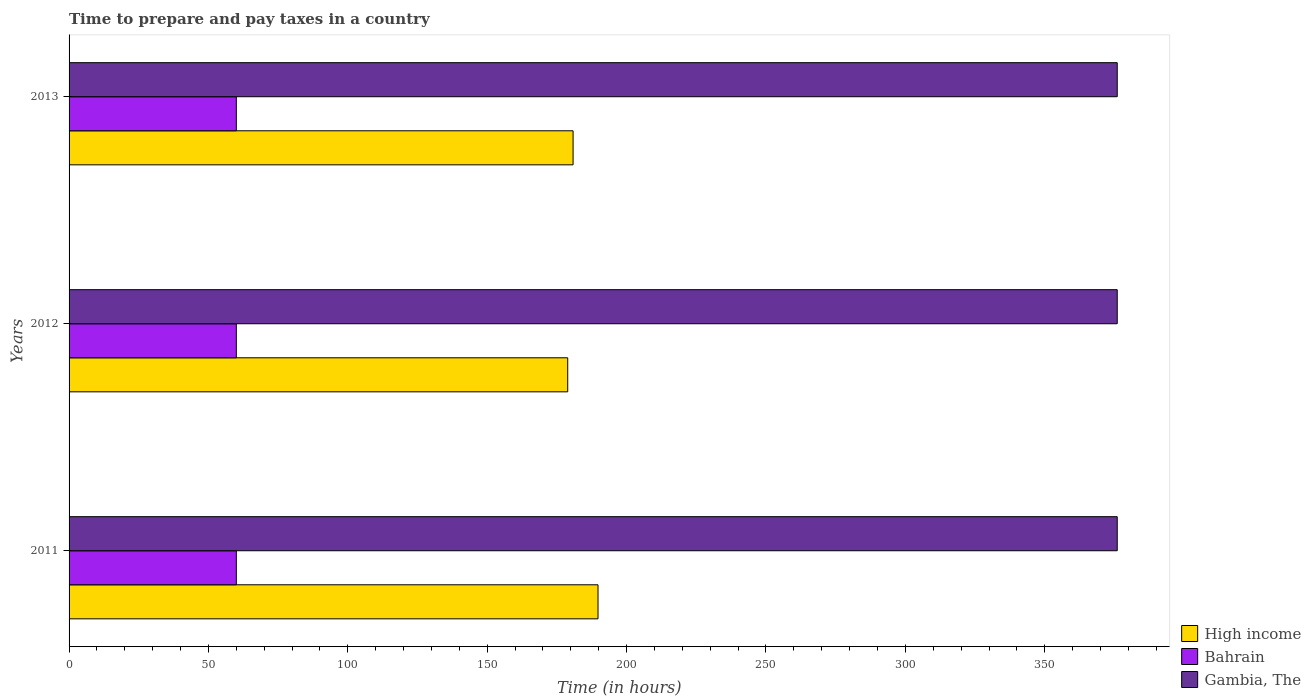How many different coloured bars are there?
Offer a very short reply. 3. Are the number of bars per tick equal to the number of legend labels?
Offer a very short reply. Yes. Are the number of bars on each tick of the Y-axis equal?
Your response must be concise. Yes. How many bars are there on the 3rd tick from the top?
Your response must be concise. 3. How many bars are there on the 3rd tick from the bottom?
Provide a short and direct response. 3. What is the label of the 3rd group of bars from the top?
Your answer should be very brief. 2011. In how many cases, is the number of bars for a given year not equal to the number of legend labels?
Your response must be concise. 0. What is the number of hours required to prepare and pay taxes in Gambia, The in 2011?
Make the answer very short. 376. Across all years, what is the maximum number of hours required to prepare and pay taxes in Bahrain?
Your answer should be compact. 60. What is the total number of hours required to prepare and pay taxes in High income in the graph?
Offer a very short reply. 549.42. What is the difference between the number of hours required to prepare and pay taxes in High income in 2013 and the number of hours required to prepare and pay taxes in Gambia, The in 2012?
Offer a very short reply. -195.2. What is the average number of hours required to prepare and pay taxes in Gambia, The per year?
Provide a succinct answer. 376. In the year 2013, what is the difference between the number of hours required to prepare and pay taxes in Bahrain and number of hours required to prepare and pay taxes in Gambia, The?
Your answer should be compact. -316. In how many years, is the number of hours required to prepare and pay taxes in High income greater than 30 hours?
Ensure brevity in your answer.  3. What is the ratio of the number of hours required to prepare and pay taxes in High income in 2012 to that in 2013?
Provide a short and direct response. 0.99. Is the number of hours required to prepare and pay taxes in Gambia, The in 2011 less than that in 2013?
Your response must be concise. No. What is the difference between the highest and the lowest number of hours required to prepare and pay taxes in High income?
Your response must be concise. 10.86. Is the sum of the number of hours required to prepare and pay taxes in Gambia, The in 2012 and 2013 greater than the maximum number of hours required to prepare and pay taxes in Bahrain across all years?
Your response must be concise. Yes. What does the 3rd bar from the top in 2012 represents?
Provide a short and direct response. High income. What does the 3rd bar from the bottom in 2013 represents?
Your response must be concise. Gambia, The. Is it the case that in every year, the sum of the number of hours required to prepare and pay taxes in Bahrain and number of hours required to prepare and pay taxes in Gambia, The is greater than the number of hours required to prepare and pay taxes in High income?
Your response must be concise. Yes. How many bars are there?
Your answer should be compact. 9. Are all the bars in the graph horizontal?
Provide a succinct answer. Yes. Are the values on the major ticks of X-axis written in scientific E-notation?
Your response must be concise. No. Where does the legend appear in the graph?
Give a very brief answer. Bottom right. What is the title of the graph?
Ensure brevity in your answer.  Time to prepare and pay taxes in a country. Does "Latvia" appear as one of the legend labels in the graph?
Make the answer very short. No. What is the label or title of the X-axis?
Provide a succinct answer. Time (in hours). What is the label or title of the Y-axis?
Offer a terse response. Years. What is the Time (in hours) in High income in 2011?
Offer a terse response. 189.74. What is the Time (in hours) in Bahrain in 2011?
Make the answer very short. 60. What is the Time (in hours) of Gambia, The in 2011?
Offer a very short reply. 376. What is the Time (in hours) in High income in 2012?
Your answer should be compact. 178.88. What is the Time (in hours) in Bahrain in 2012?
Ensure brevity in your answer.  60. What is the Time (in hours) in Gambia, The in 2012?
Your response must be concise. 376. What is the Time (in hours) of High income in 2013?
Offer a terse response. 180.8. What is the Time (in hours) of Bahrain in 2013?
Keep it short and to the point. 60. What is the Time (in hours) in Gambia, The in 2013?
Ensure brevity in your answer.  376. Across all years, what is the maximum Time (in hours) in High income?
Make the answer very short. 189.74. Across all years, what is the maximum Time (in hours) of Gambia, The?
Provide a short and direct response. 376. Across all years, what is the minimum Time (in hours) in High income?
Provide a succinct answer. 178.88. Across all years, what is the minimum Time (in hours) in Bahrain?
Provide a short and direct response. 60. Across all years, what is the minimum Time (in hours) of Gambia, The?
Ensure brevity in your answer.  376. What is the total Time (in hours) in High income in the graph?
Your answer should be compact. 549.42. What is the total Time (in hours) in Bahrain in the graph?
Provide a succinct answer. 180. What is the total Time (in hours) of Gambia, The in the graph?
Your answer should be very brief. 1128. What is the difference between the Time (in hours) in High income in 2011 and that in 2012?
Provide a short and direct response. 10.86. What is the difference between the Time (in hours) in Bahrain in 2011 and that in 2012?
Your answer should be compact. 0. What is the difference between the Time (in hours) of High income in 2011 and that in 2013?
Give a very brief answer. 8.94. What is the difference between the Time (in hours) in Gambia, The in 2011 and that in 2013?
Provide a short and direct response. 0. What is the difference between the Time (in hours) of High income in 2012 and that in 2013?
Your answer should be compact. -1.92. What is the difference between the Time (in hours) of Bahrain in 2012 and that in 2013?
Provide a succinct answer. 0. What is the difference between the Time (in hours) of Gambia, The in 2012 and that in 2013?
Provide a short and direct response. 0. What is the difference between the Time (in hours) in High income in 2011 and the Time (in hours) in Bahrain in 2012?
Keep it short and to the point. 129.74. What is the difference between the Time (in hours) in High income in 2011 and the Time (in hours) in Gambia, The in 2012?
Offer a terse response. -186.26. What is the difference between the Time (in hours) of Bahrain in 2011 and the Time (in hours) of Gambia, The in 2012?
Offer a terse response. -316. What is the difference between the Time (in hours) of High income in 2011 and the Time (in hours) of Bahrain in 2013?
Ensure brevity in your answer.  129.74. What is the difference between the Time (in hours) of High income in 2011 and the Time (in hours) of Gambia, The in 2013?
Offer a terse response. -186.26. What is the difference between the Time (in hours) in Bahrain in 2011 and the Time (in hours) in Gambia, The in 2013?
Offer a very short reply. -316. What is the difference between the Time (in hours) of High income in 2012 and the Time (in hours) of Bahrain in 2013?
Your answer should be compact. 118.88. What is the difference between the Time (in hours) of High income in 2012 and the Time (in hours) of Gambia, The in 2013?
Provide a succinct answer. -197.12. What is the difference between the Time (in hours) of Bahrain in 2012 and the Time (in hours) of Gambia, The in 2013?
Offer a very short reply. -316. What is the average Time (in hours) in High income per year?
Offer a very short reply. 183.14. What is the average Time (in hours) of Bahrain per year?
Provide a succinct answer. 60. What is the average Time (in hours) in Gambia, The per year?
Your answer should be compact. 376. In the year 2011, what is the difference between the Time (in hours) in High income and Time (in hours) in Bahrain?
Your answer should be compact. 129.74. In the year 2011, what is the difference between the Time (in hours) in High income and Time (in hours) in Gambia, The?
Offer a terse response. -186.26. In the year 2011, what is the difference between the Time (in hours) in Bahrain and Time (in hours) in Gambia, The?
Offer a very short reply. -316. In the year 2012, what is the difference between the Time (in hours) of High income and Time (in hours) of Bahrain?
Offer a very short reply. 118.88. In the year 2012, what is the difference between the Time (in hours) of High income and Time (in hours) of Gambia, The?
Your response must be concise. -197.12. In the year 2012, what is the difference between the Time (in hours) of Bahrain and Time (in hours) of Gambia, The?
Make the answer very short. -316. In the year 2013, what is the difference between the Time (in hours) in High income and Time (in hours) in Bahrain?
Provide a short and direct response. 120.8. In the year 2013, what is the difference between the Time (in hours) in High income and Time (in hours) in Gambia, The?
Your answer should be very brief. -195.2. In the year 2013, what is the difference between the Time (in hours) in Bahrain and Time (in hours) in Gambia, The?
Make the answer very short. -316. What is the ratio of the Time (in hours) of High income in 2011 to that in 2012?
Your answer should be compact. 1.06. What is the ratio of the Time (in hours) of Bahrain in 2011 to that in 2012?
Your answer should be compact. 1. What is the ratio of the Time (in hours) in Gambia, The in 2011 to that in 2012?
Your answer should be very brief. 1. What is the ratio of the Time (in hours) in High income in 2011 to that in 2013?
Offer a very short reply. 1.05. What is the ratio of the Time (in hours) in Bahrain in 2011 to that in 2013?
Make the answer very short. 1. What is the ratio of the Time (in hours) of Gambia, The in 2011 to that in 2013?
Offer a terse response. 1. What is the ratio of the Time (in hours) in Gambia, The in 2012 to that in 2013?
Your answer should be very brief. 1. What is the difference between the highest and the second highest Time (in hours) in High income?
Make the answer very short. 8.94. What is the difference between the highest and the second highest Time (in hours) of Gambia, The?
Your answer should be compact. 0. What is the difference between the highest and the lowest Time (in hours) in High income?
Ensure brevity in your answer.  10.86. What is the difference between the highest and the lowest Time (in hours) in Bahrain?
Your answer should be very brief. 0. What is the difference between the highest and the lowest Time (in hours) of Gambia, The?
Make the answer very short. 0. 